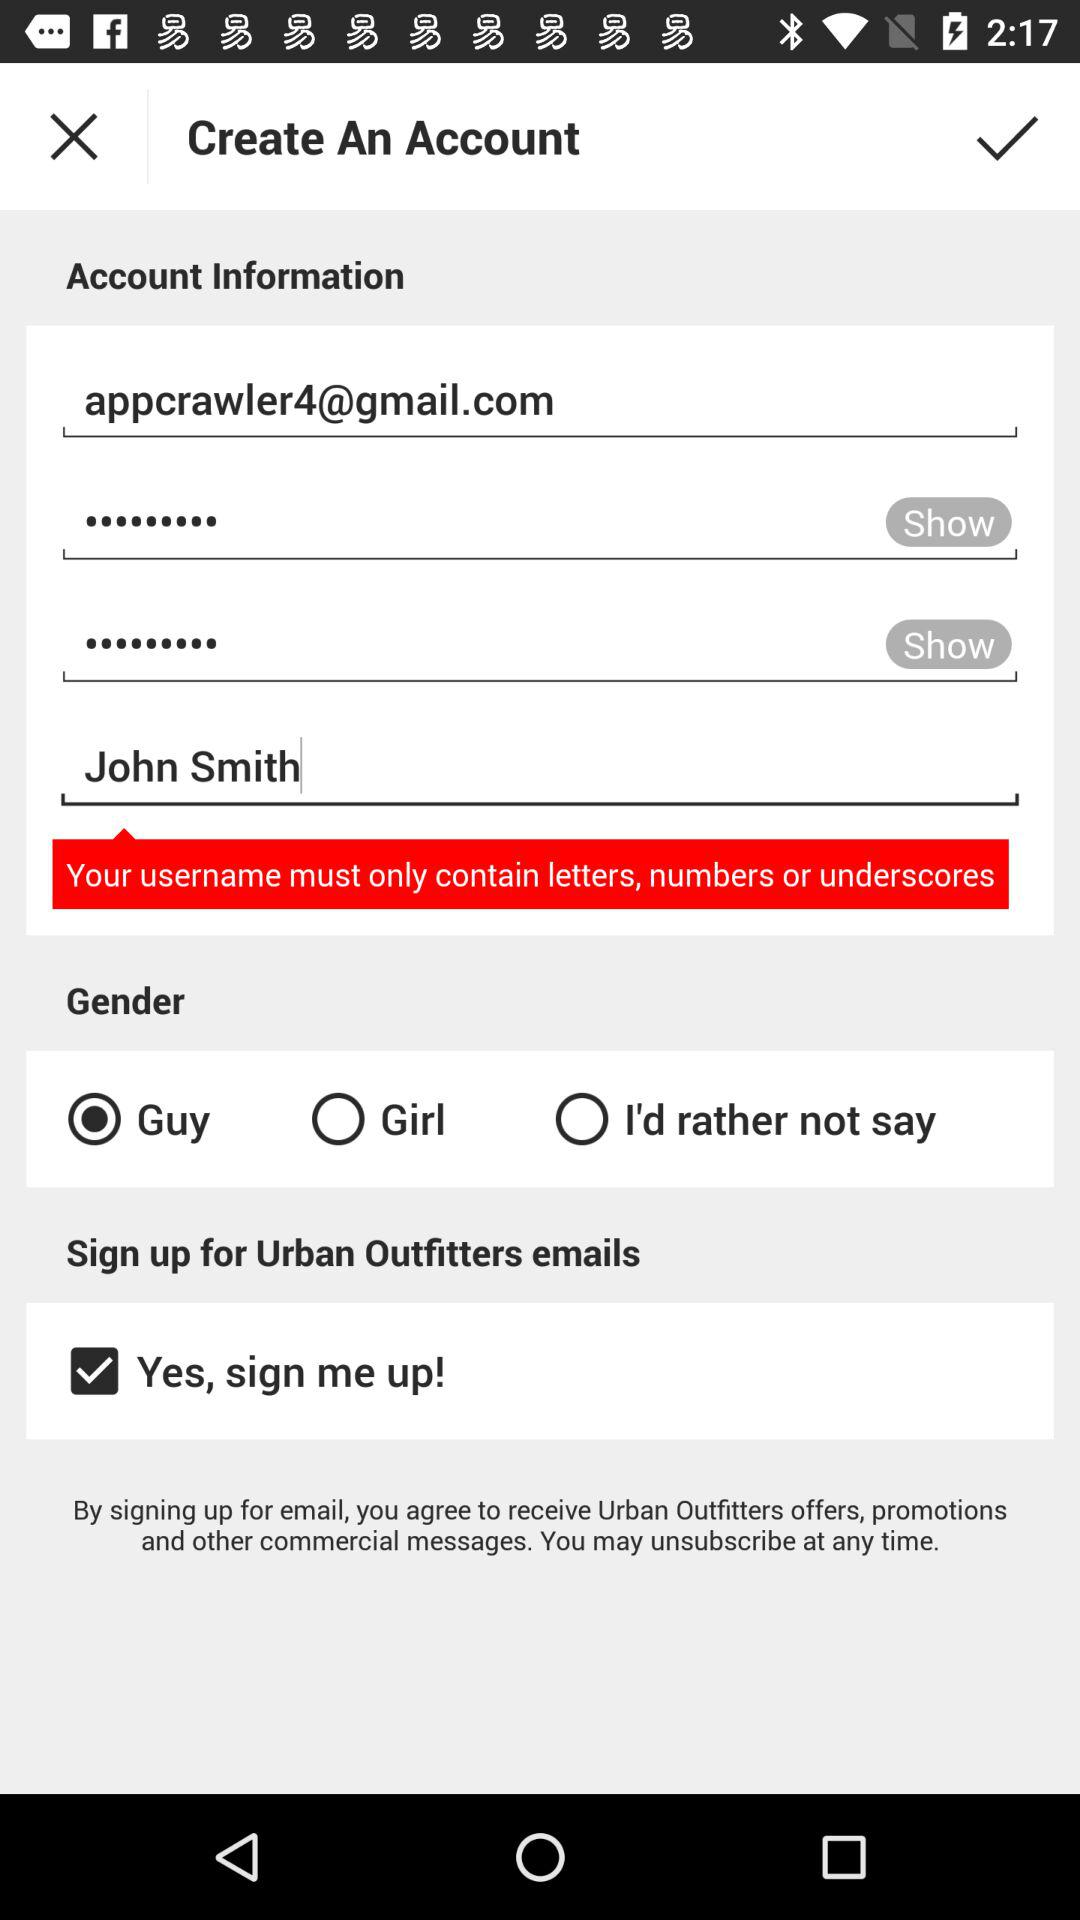What is the user name? The user name is John Smith. 